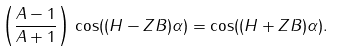<formula> <loc_0><loc_0><loc_500><loc_500>\left ( \frac { A - 1 } { A + 1 } \right ) \, \cos ( ( H - Z B ) \alpha ) = \cos ( ( H + Z B ) \alpha ) .</formula> 